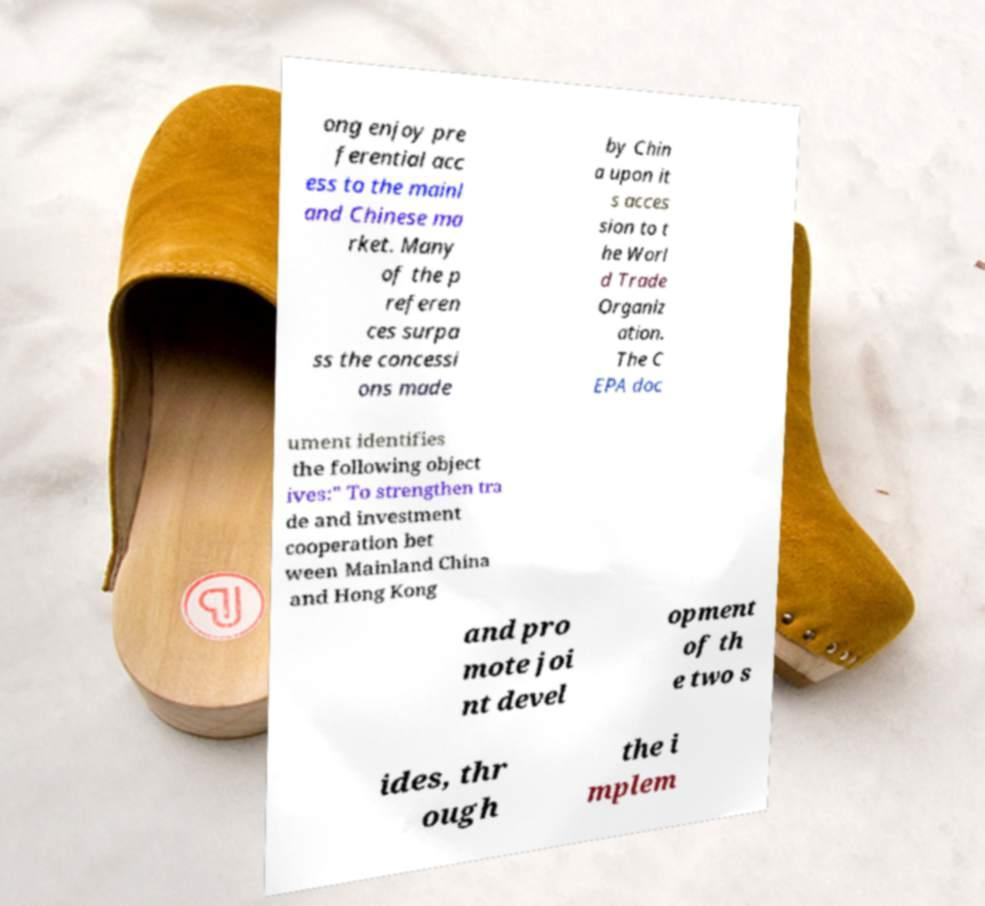Please read and relay the text visible in this image. What does it say? ong enjoy pre ferential acc ess to the mainl and Chinese ma rket. Many of the p referen ces surpa ss the concessi ons made by Chin a upon it s acces sion to t he Worl d Trade Organiz ation. The C EPA doc ument identifies the following object ives:" To strengthen tra de and investment cooperation bet ween Mainland China and Hong Kong and pro mote joi nt devel opment of th e two s ides, thr ough the i mplem 